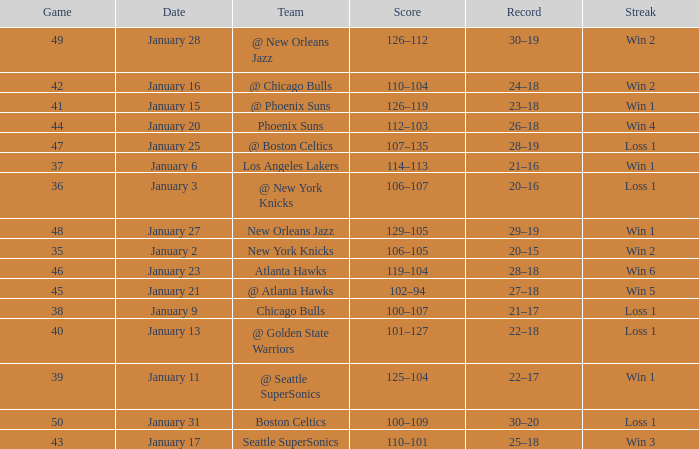What is the Team in Game 38? Chicago Bulls. 